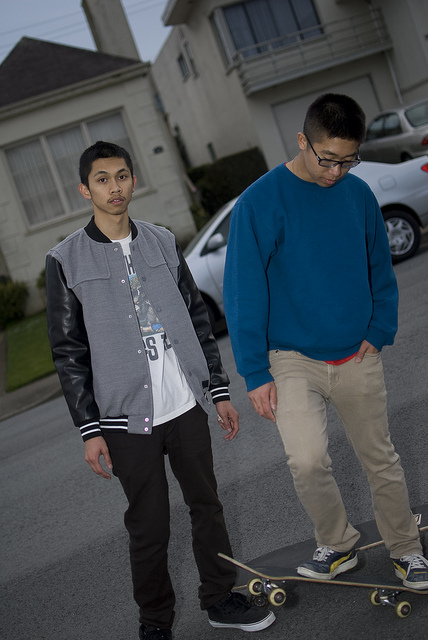Describe the setting of this image. The photo depicts an overcast day in a serene residential area with houses lining the street and a solitary car parked. The focus is on two young individuals, capturing a moment in their daily life. 